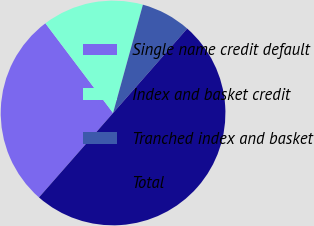<chart> <loc_0><loc_0><loc_500><loc_500><pie_chart><fcel>Single name credit default<fcel>Index and basket credit<fcel>Tranched index and basket<fcel>Total<nl><fcel>28.25%<fcel>14.57%<fcel>7.19%<fcel>50.0%<nl></chart> 